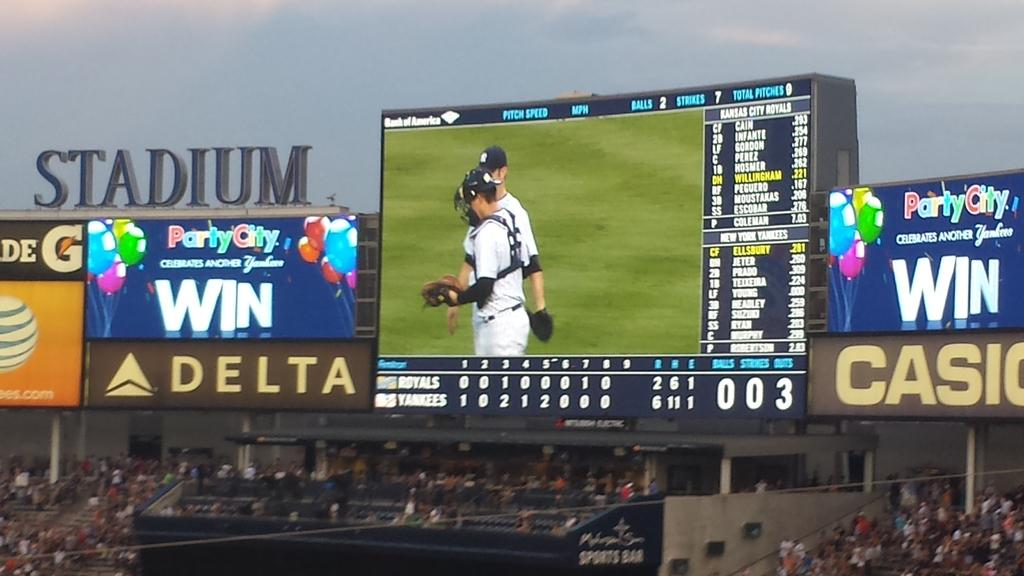<image>
Relay a brief, clear account of the picture shown. A baseball game is underway and there are ads for Delta and Casio on the stadium. 